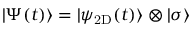<formula> <loc_0><loc_0><loc_500><loc_500>| \Psi ( t ) \rangle = | \psi _ { 2 D } ( t ) \rangle \otimes | \sigma \rangle</formula> 